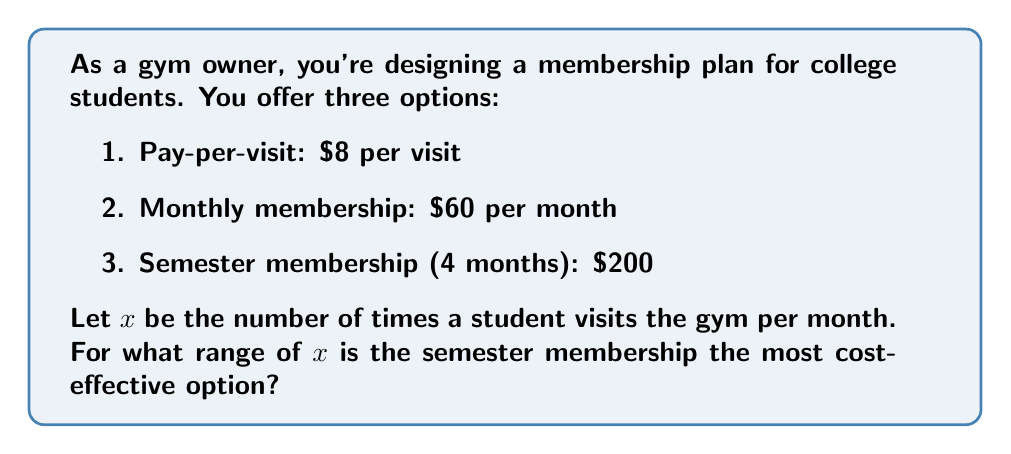Solve this math problem. To solve this problem, we need to compare the cost of each option over a 4-month period (one semester):

1. Pay-per-visit: $32x$ (4 months * $8x$ per month)
2. Monthly membership: $240$ (4 * $60$)
3. Semester membership: $200$

The semester membership is the most cost-effective when it's cheaper than both other options:

$$200 < 32x \text{ and } 200 < 240$$

From the second inequality, we can see that the semester membership is always cheaper than the monthly membership.

For the first inequality:
$$200 < 32x$$
$$\frac{200}{32} < x$$
$$6.25 < x$$

Since $x$ represents the number of visits per month, we need to round up to the nearest whole number:
$$7 \leq x$$

For the upper bound, we compare the semester membership to the pay-per-visit option:
$$32x < 200$$
$$x < \frac{200}{32} = 6.25$$

The largest whole number of visits for which the semester membership is cheaper is 6.

Therefore, the semester membership is the most cost-effective option when a student visits the gym 7 to infinity times per month.
Answer: The semester membership is the most cost-effective option when $x \geq 7$, where $x$ is the number of times a student visits the gym per month. 